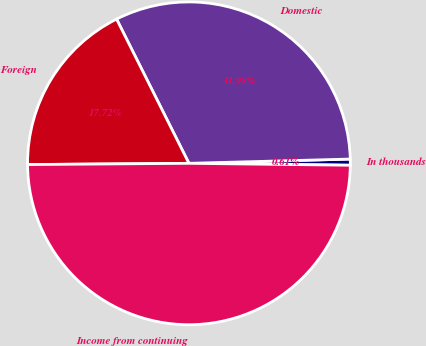Convert chart. <chart><loc_0><loc_0><loc_500><loc_500><pie_chart><fcel>In thousands<fcel>Domestic<fcel>Foreign<fcel>Income from continuing<nl><fcel>0.61%<fcel>31.98%<fcel>17.72%<fcel>49.69%<nl></chart> 